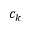Convert formula to latex. <formula><loc_0><loc_0><loc_500><loc_500>c _ { k }</formula> 